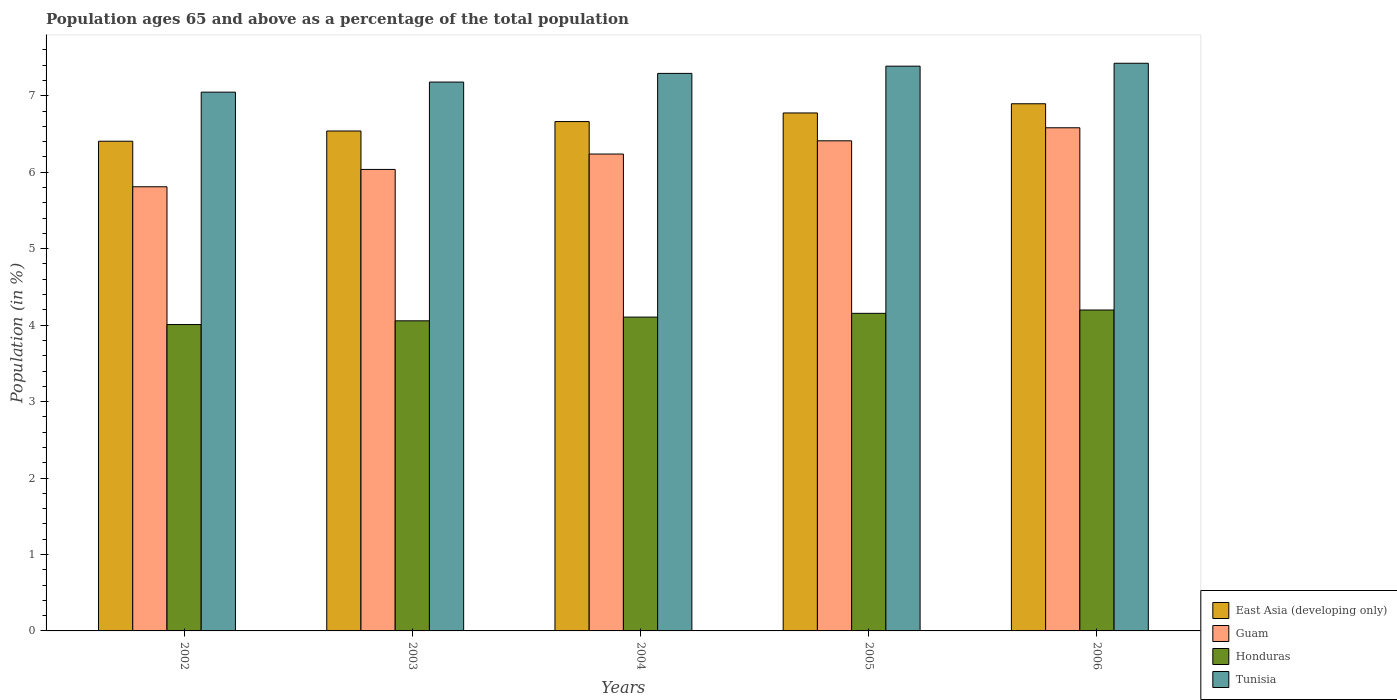How many groups of bars are there?
Provide a succinct answer. 5. How many bars are there on the 4th tick from the right?
Provide a short and direct response. 4. What is the label of the 2nd group of bars from the left?
Provide a succinct answer. 2003. In how many cases, is the number of bars for a given year not equal to the number of legend labels?
Offer a very short reply. 0. What is the percentage of the population ages 65 and above in East Asia (developing only) in 2006?
Your answer should be very brief. 6.9. Across all years, what is the maximum percentage of the population ages 65 and above in East Asia (developing only)?
Give a very brief answer. 6.9. Across all years, what is the minimum percentage of the population ages 65 and above in Guam?
Provide a short and direct response. 5.81. In which year was the percentage of the population ages 65 and above in Guam maximum?
Your answer should be compact. 2006. In which year was the percentage of the population ages 65 and above in Honduras minimum?
Provide a short and direct response. 2002. What is the total percentage of the population ages 65 and above in East Asia (developing only) in the graph?
Provide a short and direct response. 33.28. What is the difference between the percentage of the population ages 65 and above in Honduras in 2005 and that in 2006?
Offer a very short reply. -0.04. What is the difference between the percentage of the population ages 65 and above in Honduras in 2006 and the percentage of the population ages 65 and above in Guam in 2002?
Your answer should be compact. -1.61. What is the average percentage of the population ages 65 and above in Guam per year?
Offer a very short reply. 6.22. In the year 2002, what is the difference between the percentage of the population ages 65 and above in Guam and percentage of the population ages 65 and above in Tunisia?
Provide a succinct answer. -1.24. In how many years, is the percentage of the population ages 65 and above in Guam greater than 6.8?
Offer a very short reply. 0. What is the ratio of the percentage of the population ages 65 and above in Guam in 2003 to that in 2004?
Your response must be concise. 0.97. Is the difference between the percentage of the population ages 65 and above in Guam in 2002 and 2003 greater than the difference between the percentage of the population ages 65 and above in Tunisia in 2002 and 2003?
Offer a very short reply. No. What is the difference between the highest and the second highest percentage of the population ages 65 and above in Honduras?
Your answer should be very brief. 0.04. What is the difference between the highest and the lowest percentage of the population ages 65 and above in Honduras?
Offer a terse response. 0.19. In how many years, is the percentage of the population ages 65 and above in Guam greater than the average percentage of the population ages 65 and above in Guam taken over all years?
Make the answer very short. 3. Is the sum of the percentage of the population ages 65 and above in Guam in 2004 and 2006 greater than the maximum percentage of the population ages 65 and above in Tunisia across all years?
Keep it short and to the point. Yes. Is it the case that in every year, the sum of the percentage of the population ages 65 and above in East Asia (developing only) and percentage of the population ages 65 and above in Guam is greater than the sum of percentage of the population ages 65 and above in Tunisia and percentage of the population ages 65 and above in Honduras?
Keep it short and to the point. No. What does the 2nd bar from the left in 2002 represents?
Give a very brief answer. Guam. What does the 2nd bar from the right in 2002 represents?
Your answer should be very brief. Honduras. Is it the case that in every year, the sum of the percentage of the population ages 65 and above in East Asia (developing only) and percentage of the population ages 65 and above in Guam is greater than the percentage of the population ages 65 and above in Tunisia?
Your answer should be compact. Yes. How many bars are there?
Provide a short and direct response. 20. Are all the bars in the graph horizontal?
Ensure brevity in your answer.  No. What is the difference between two consecutive major ticks on the Y-axis?
Provide a short and direct response. 1. Are the values on the major ticks of Y-axis written in scientific E-notation?
Provide a short and direct response. No. How are the legend labels stacked?
Ensure brevity in your answer.  Vertical. What is the title of the graph?
Offer a very short reply. Population ages 65 and above as a percentage of the total population. Does "Equatorial Guinea" appear as one of the legend labels in the graph?
Provide a short and direct response. No. What is the label or title of the X-axis?
Make the answer very short. Years. What is the label or title of the Y-axis?
Make the answer very short. Population (in %). What is the Population (in %) in East Asia (developing only) in 2002?
Offer a very short reply. 6.41. What is the Population (in %) in Guam in 2002?
Provide a short and direct response. 5.81. What is the Population (in %) in Honduras in 2002?
Offer a very short reply. 4.01. What is the Population (in %) of Tunisia in 2002?
Provide a succinct answer. 7.05. What is the Population (in %) of East Asia (developing only) in 2003?
Offer a very short reply. 6.54. What is the Population (in %) of Guam in 2003?
Give a very brief answer. 6.04. What is the Population (in %) in Honduras in 2003?
Make the answer very short. 4.06. What is the Population (in %) in Tunisia in 2003?
Offer a very short reply. 7.18. What is the Population (in %) of East Asia (developing only) in 2004?
Provide a short and direct response. 6.66. What is the Population (in %) of Guam in 2004?
Your response must be concise. 6.24. What is the Population (in %) of Honduras in 2004?
Give a very brief answer. 4.11. What is the Population (in %) of Tunisia in 2004?
Keep it short and to the point. 7.29. What is the Population (in %) in East Asia (developing only) in 2005?
Keep it short and to the point. 6.78. What is the Population (in %) of Guam in 2005?
Your response must be concise. 6.41. What is the Population (in %) in Honduras in 2005?
Provide a short and direct response. 4.15. What is the Population (in %) in Tunisia in 2005?
Ensure brevity in your answer.  7.39. What is the Population (in %) in East Asia (developing only) in 2006?
Offer a very short reply. 6.9. What is the Population (in %) of Guam in 2006?
Offer a terse response. 6.58. What is the Population (in %) in Honduras in 2006?
Ensure brevity in your answer.  4.2. What is the Population (in %) in Tunisia in 2006?
Provide a short and direct response. 7.43. Across all years, what is the maximum Population (in %) in East Asia (developing only)?
Your answer should be compact. 6.9. Across all years, what is the maximum Population (in %) in Guam?
Your answer should be very brief. 6.58. Across all years, what is the maximum Population (in %) of Honduras?
Offer a very short reply. 4.2. Across all years, what is the maximum Population (in %) of Tunisia?
Ensure brevity in your answer.  7.43. Across all years, what is the minimum Population (in %) of East Asia (developing only)?
Your answer should be very brief. 6.41. Across all years, what is the minimum Population (in %) in Guam?
Offer a very short reply. 5.81. Across all years, what is the minimum Population (in %) in Honduras?
Your answer should be very brief. 4.01. Across all years, what is the minimum Population (in %) in Tunisia?
Provide a succinct answer. 7.05. What is the total Population (in %) in East Asia (developing only) in the graph?
Your answer should be compact. 33.28. What is the total Population (in %) of Guam in the graph?
Offer a very short reply. 31.08. What is the total Population (in %) in Honduras in the graph?
Your answer should be compact. 20.52. What is the total Population (in %) of Tunisia in the graph?
Ensure brevity in your answer.  36.34. What is the difference between the Population (in %) in East Asia (developing only) in 2002 and that in 2003?
Keep it short and to the point. -0.13. What is the difference between the Population (in %) in Guam in 2002 and that in 2003?
Keep it short and to the point. -0.23. What is the difference between the Population (in %) of Honduras in 2002 and that in 2003?
Provide a short and direct response. -0.05. What is the difference between the Population (in %) in Tunisia in 2002 and that in 2003?
Offer a very short reply. -0.13. What is the difference between the Population (in %) of East Asia (developing only) in 2002 and that in 2004?
Provide a succinct answer. -0.26. What is the difference between the Population (in %) in Guam in 2002 and that in 2004?
Provide a succinct answer. -0.43. What is the difference between the Population (in %) in Honduras in 2002 and that in 2004?
Offer a terse response. -0.1. What is the difference between the Population (in %) of Tunisia in 2002 and that in 2004?
Ensure brevity in your answer.  -0.25. What is the difference between the Population (in %) in East Asia (developing only) in 2002 and that in 2005?
Your response must be concise. -0.37. What is the difference between the Population (in %) of Guam in 2002 and that in 2005?
Ensure brevity in your answer.  -0.6. What is the difference between the Population (in %) in Honduras in 2002 and that in 2005?
Offer a terse response. -0.15. What is the difference between the Population (in %) of Tunisia in 2002 and that in 2005?
Make the answer very short. -0.34. What is the difference between the Population (in %) of East Asia (developing only) in 2002 and that in 2006?
Your answer should be very brief. -0.49. What is the difference between the Population (in %) in Guam in 2002 and that in 2006?
Your answer should be compact. -0.77. What is the difference between the Population (in %) of Honduras in 2002 and that in 2006?
Your answer should be very brief. -0.19. What is the difference between the Population (in %) of Tunisia in 2002 and that in 2006?
Offer a very short reply. -0.38. What is the difference between the Population (in %) in East Asia (developing only) in 2003 and that in 2004?
Provide a succinct answer. -0.12. What is the difference between the Population (in %) in Guam in 2003 and that in 2004?
Provide a succinct answer. -0.2. What is the difference between the Population (in %) of Honduras in 2003 and that in 2004?
Your answer should be very brief. -0.05. What is the difference between the Population (in %) of Tunisia in 2003 and that in 2004?
Provide a succinct answer. -0.11. What is the difference between the Population (in %) of East Asia (developing only) in 2003 and that in 2005?
Your response must be concise. -0.24. What is the difference between the Population (in %) of Guam in 2003 and that in 2005?
Ensure brevity in your answer.  -0.37. What is the difference between the Population (in %) in Honduras in 2003 and that in 2005?
Your response must be concise. -0.1. What is the difference between the Population (in %) of Tunisia in 2003 and that in 2005?
Your response must be concise. -0.21. What is the difference between the Population (in %) of East Asia (developing only) in 2003 and that in 2006?
Give a very brief answer. -0.36. What is the difference between the Population (in %) of Guam in 2003 and that in 2006?
Keep it short and to the point. -0.55. What is the difference between the Population (in %) in Honduras in 2003 and that in 2006?
Provide a succinct answer. -0.14. What is the difference between the Population (in %) in Tunisia in 2003 and that in 2006?
Offer a terse response. -0.25. What is the difference between the Population (in %) in East Asia (developing only) in 2004 and that in 2005?
Offer a terse response. -0.11. What is the difference between the Population (in %) in Guam in 2004 and that in 2005?
Your response must be concise. -0.17. What is the difference between the Population (in %) of Honduras in 2004 and that in 2005?
Ensure brevity in your answer.  -0.05. What is the difference between the Population (in %) of Tunisia in 2004 and that in 2005?
Your response must be concise. -0.09. What is the difference between the Population (in %) of East Asia (developing only) in 2004 and that in 2006?
Offer a very short reply. -0.23. What is the difference between the Population (in %) of Guam in 2004 and that in 2006?
Ensure brevity in your answer.  -0.34. What is the difference between the Population (in %) in Honduras in 2004 and that in 2006?
Offer a terse response. -0.09. What is the difference between the Population (in %) in Tunisia in 2004 and that in 2006?
Ensure brevity in your answer.  -0.13. What is the difference between the Population (in %) of East Asia (developing only) in 2005 and that in 2006?
Your response must be concise. -0.12. What is the difference between the Population (in %) in Guam in 2005 and that in 2006?
Give a very brief answer. -0.17. What is the difference between the Population (in %) of Honduras in 2005 and that in 2006?
Your answer should be compact. -0.04. What is the difference between the Population (in %) of Tunisia in 2005 and that in 2006?
Offer a terse response. -0.04. What is the difference between the Population (in %) of East Asia (developing only) in 2002 and the Population (in %) of Guam in 2003?
Your response must be concise. 0.37. What is the difference between the Population (in %) of East Asia (developing only) in 2002 and the Population (in %) of Honduras in 2003?
Keep it short and to the point. 2.35. What is the difference between the Population (in %) in East Asia (developing only) in 2002 and the Population (in %) in Tunisia in 2003?
Give a very brief answer. -0.77. What is the difference between the Population (in %) of Guam in 2002 and the Population (in %) of Honduras in 2003?
Your response must be concise. 1.75. What is the difference between the Population (in %) in Guam in 2002 and the Population (in %) in Tunisia in 2003?
Keep it short and to the point. -1.37. What is the difference between the Population (in %) of Honduras in 2002 and the Population (in %) of Tunisia in 2003?
Keep it short and to the point. -3.17. What is the difference between the Population (in %) of East Asia (developing only) in 2002 and the Population (in %) of Guam in 2004?
Keep it short and to the point. 0.17. What is the difference between the Population (in %) of East Asia (developing only) in 2002 and the Population (in %) of Honduras in 2004?
Provide a short and direct response. 2.3. What is the difference between the Population (in %) in East Asia (developing only) in 2002 and the Population (in %) in Tunisia in 2004?
Your answer should be compact. -0.89. What is the difference between the Population (in %) in Guam in 2002 and the Population (in %) in Honduras in 2004?
Your response must be concise. 1.7. What is the difference between the Population (in %) of Guam in 2002 and the Population (in %) of Tunisia in 2004?
Your answer should be very brief. -1.48. What is the difference between the Population (in %) in Honduras in 2002 and the Population (in %) in Tunisia in 2004?
Your answer should be compact. -3.29. What is the difference between the Population (in %) of East Asia (developing only) in 2002 and the Population (in %) of Guam in 2005?
Make the answer very short. -0.01. What is the difference between the Population (in %) of East Asia (developing only) in 2002 and the Population (in %) of Honduras in 2005?
Offer a very short reply. 2.25. What is the difference between the Population (in %) of East Asia (developing only) in 2002 and the Population (in %) of Tunisia in 2005?
Your answer should be very brief. -0.98. What is the difference between the Population (in %) in Guam in 2002 and the Population (in %) in Honduras in 2005?
Offer a terse response. 1.66. What is the difference between the Population (in %) of Guam in 2002 and the Population (in %) of Tunisia in 2005?
Your response must be concise. -1.58. What is the difference between the Population (in %) in Honduras in 2002 and the Population (in %) in Tunisia in 2005?
Provide a succinct answer. -3.38. What is the difference between the Population (in %) in East Asia (developing only) in 2002 and the Population (in %) in Guam in 2006?
Provide a short and direct response. -0.18. What is the difference between the Population (in %) of East Asia (developing only) in 2002 and the Population (in %) of Honduras in 2006?
Make the answer very short. 2.21. What is the difference between the Population (in %) of East Asia (developing only) in 2002 and the Population (in %) of Tunisia in 2006?
Offer a terse response. -1.02. What is the difference between the Population (in %) in Guam in 2002 and the Population (in %) in Honduras in 2006?
Provide a short and direct response. 1.61. What is the difference between the Population (in %) in Guam in 2002 and the Population (in %) in Tunisia in 2006?
Keep it short and to the point. -1.62. What is the difference between the Population (in %) of Honduras in 2002 and the Population (in %) of Tunisia in 2006?
Give a very brief answer. -3.42. What is the difference between the Population (in %) of East Asia (developing only) in 2003 and the Population (in %) of Guam in 2004?
Ensure brevity in your answer.  0.3. What is the difference between the Population (in %) of East Asia (developing only) in 2003 and the Population (in %) of Honduras in 2004?
Your answer should be compact. 2.43. What is the difference between the Population (in %) in East Asia (developing only) in 2003 and the Population (in %) in Tunisia in 2004?
Offer a terse response. -0.75. What is the difference between the Population (in %) of Guam in 2003 and the Population (in %) of Honduras in 2004?
Provide a short and direct response. 1.93. What is the difference between the Population (in %) of Guam in 2003 and the Population (in %) of Tunisia in 2004?
Provide a short and direct response. -1.26. What is the difference between the Population (in %) in Honduras in 2003 and the Population (in %) in Tunisia in 2004?
Ensure brevity in your answer.  -3.24. What is the difference between the Population (in %) in East Asia (developing only) in 2003 and the Population (in %) in Guam in 2005?
Offer a terse response. 0.13. What is the difference between the Population (in %) of East Asia (developing only) in 2003 and the Population (in %) of Honduras in 2005?
Keep it short and to the point. 2.39. What is the difference between the Population (in %) in East Asia (developing only) in 2003 and the Population (in %) in Tunisia in 2005?
Your answer should be very brief. -0.85. What is the difference between the Population (in %) in Guam in 2003 and the Population (in %) in Honduras in 2005?
Offer a terse response. 1.88. What is the difference between the Population (in %) of Guam in 2003 and the Population (in %) of Tunisia in 2005?
Provide a succinct answer. -1.35. What is the difference between the Population (in %) in Honduras in 2003 and the Population (in %) in Tunisia in 2005?
Your answer should be compact. -3.33. What is the difference between the Population (in %) of East Asia (developing only) in 2003 and the Population (in %) of Guam in 2006?
Your answer should be very brief. -0.04. What is the difference between the Population (in %) of East Asia (developing only) in 2003 and the Population (in %) of Honduras in 2006?
Provide a short and direct response. 2.34. What is the difference between the Population (in %) of East Asia (developing only) in 2003 and the Population (in %) of Tunisia in 2006?
Offer a terse response. -0.89. What is the difference between the Population (in %) of Guam in 2003 and the Population (in %) of Honduras in 2006?
Ensure brevity in your answer.  1.84. What is the difference between the Population (in %) in Guam in 2003 and the Population (in %) in Tunisia in 2006?
Provide a short and direct response. -1.39. What is the difference between the Population (in %) of Honduras in 2003 and the Population (in %) of Tunisia in 2006?
Give a very brief answer. -3.37. What is the difference between the Population (in %) of East Asia (developing only) in 2004 and the Population (in %) of Guam in 2005?
Provide a succinct answer. 0.25. What is the difference between the Population (in %) in East Asia (developing only) in 2004 and the Population (in %) in Honduras in 2005?
Your response must be concise. 2.51. What is the difference between the Population (in %) in East Asia (developing only) in 2004 and the Population (in %) in Tunisia in 2005?
Your answer should be very brief. -0.72. What is the difference between the Population (in %) of Guam in 2004 and the Population (in %) of Honduras in 2005?
Offer a terse response. 2.08. What is the difference between the Population (in %) in Guam in 2004 and the Population (in %) in Tunisia in 2005?
Keep it short and to the point. -1.15. What is the difference between the Population (in %) of Honduras in 2004 and the Population (in %) of Tunisia in 2005?
Your answer should be very brief. -3.28. What is the difference between the Population (in %) of East Asia (developing only) in 2004 and the Population (in %) of Guam in 2006?
Keep it short and to the point. 0.08. What is the difference between the Population (in %) in East Asia (developing only) in 2004 and the Population (in %) in Honduras in 2006?
Your answer should be compact. 2.46. What is the difference between the Population (in %) of East Asia (developing only) in 2004 and the Population (in %) of Tunisia in 2006?
Give a very brief answer. -0.76. What is the difference between the Population (in %) of Guam in 2004 and the Population (in %) of Honduras in 2006?
Keep it short and to the point. 2.04. What is the difference between the Population (in %) in Guam in 2004 and the Population (in %) in Tunisia in 2006?
Your answer should be very brief. -1.19. What is the difference between the Population (in %) of Honduras in 2004 and the Population (in %) of Tunisia in 2006?
Ensure brevity in your answer.  -3.32. What is the difference between the Population (in %) of East Asia (developing only) in 2005 and the Population (in %) of Guam in 2006?
Offer a terse response. 0.19. What is the difference between the Population (in %) of East Asia (developing only) in 2005 and the Population (in %) of Honduras in 2006?
Keep it short and to the point. 2.58. What is the difference between the Population (in %) of East Asia (developing only) in 2005 and the Population (in %) of Tunisia in 2006?
Provide a succinct answer. -0.65. What is the difference between the Population (in %) of Guam in 2005 and the Population (in %) of Honduras in 2006?
Ensure brevity in your answer.  2.21. What is the difference between the Population (in %) of Guam in 2005 and the Population (in %) of Tunisia in 2006?
Provide a short and direct response. -1.01. What is the difference between the Population (in %) in Honduras in 2005 and the Population (in %) in Tunisia in 2006?
Your response must be concise. -3.27. What is the average Population (in %) in East Asia (developing only) per year?
Ensure brevity in your answer.  6.66. What is the average Population (in %) in Guam per year?
Keep it short and to the point. 6.22. What is the average Population (in %) of Honduras per year?
Make the answer very short. 4.1. What is the average Population (in %) of Tunisia per year?
Ensure brevity in your answer.  7.27. In the year 2002, what is the difference between the Population (in %) in East Asia (developing only) and Population (in %) in Guam?
Offer a very short reply. 0.6. In the year 2002, what is the difference between the Population (in %) of East Asia (developing only) and Population (in %) of Honduras?
Give a very brief answer. 2.4. In the year 2002, what is the difference between the Population (in %) in East Asia (developing only) and Population (in %) in Tunisia?
Offer a terse response. -0.64. In the year 2002, what is the difference between the Population (in %) in Guam and Population (in %) in Honduras?
Make the answer very short. 1.8. In the year 2002, what is the difference between the Population (in %) of Guam and Population (in %) of Tunisia?
Provide a succinct answer. -1.24. In the year 2002, what is the difference between the Population (in %) of Honduras and Population (in %) of Tunisia?
Your answer should be very brief. -3.04. In the year 2003, what is the difference between the Population (in %) of East Asia (developing only) and Population (in %) of Guam?
Provide a succinct answer. 0.5. In the year 2003, what is the difference between the Population (in %) of East Asia (developing only) and Population (in %) of Honduras?
Your answer should be very brief. 2.48. In the year 2003, what is the difference between the Population (in %) of East Asia (developing only) and Population (in %) of Tunisia?
Provide a succinct answer. -0.64. In the year 2003, what is the difference between the Population (in %) of Guam and Population (in %) of Honduras?
Provide a succinct answer. 1.98. In the year 2003, what is the difference between the Population (in %) in Guam and Population (in %) in Tunisia?
Your answer should be compact. -1.14. In the year 2003, what is the difference between the Population (in %) of Honduras and Population (in %) of Tunisia?
Provide a succinct answer. -3.12. In the year 2004, what is the difference between the Population (in %) in East Asia (developing only) and Population (in %) in Guam?
Your response must be concise. 0.42. In the year 2004, what is the difference between the Population (in %) of East Asia (developing only) and Population (in %) of Honduras?
Your answer should be very brief. 2.56. In the year 2004, what is the difference between the Population (in %) of East Asia (developing only) and Population (in %) of Tunisia?
Offer a very short reply. -0.63. In the year 2004, what is the difference between the Population (in %) in Guam and Population (in %) in Honduras?
Make the answer very short. 2.13. In the year 2004, what is the difference between the Population (in %) of Guam and Population (in %) of Tunisia?
Provide a succinct answer. -1.05. In the year 2004, what is the difference between the Population (in %) of Honduras and Population (in %) of Tunisia?
Offer a terse response. -3.19. In the year 2005, what is the difference between the Population (in %) in East Asia (developing only) and Population (in %) in Guam?
Provide a short and direct response. 0.36. In the year 2005, what is the difference between the Population (in %) in East Asia (developing only) and Population (in %) in Honduras?
Provide a short and direct response. 2.62. In the year 2005, what is the difference between the Population (in %) in East Asia (developing only) and Population (in %) in Tunisia?
Provide a short and direct response. -0.61. In the year 2005, what is the difference between the Population (in %) of Guam and Population (in %) of Honduras?
Your answer should be compact. 2.26. In the year 2005, what is the difference between the Population (in %) of Guam and Population (in %) of Tunisia?
Offer a very short reply. -0.98. In the year 2005, what is the difference between the Population (in %) of Honduras and Population (in %) of Tunisia?
Make the answer very short. -3.23. In the year 2006, what is the difference between the Population (in %) of East Asia (developing only) and Population (in %) of Guam?
Provide a succinct answer. 0.31. In the year 2006, what is the difference between the Population (in %) in East Asia (developing only) and Population (in %) in Honduras?
Your answer should be compact. 2.7. In the year 2006, what is the difference between the Population (in %) in East Asia (developing only) and Population (in %) in Tunisia?
Your answer should be compact. -0.53. In the year 2006, what is the difference between the Population (in %) in Guam and Population (in %) in Honduras?
Give a very brief answer. 2.38. In the year 2006, what is the difference between the Population (in %) of Guam and Population (in %) of Tunisia?
Ensure brevity in your answer.  -0.84. In the year 2006, what is the difference between the Population (in %) in Honduras and Population (in %) in Tunisia?
Keep it short and to the point. -3.23. What is the ratio of the Population (in %) in East Asia (developing only) in 2002 to that in 2003?
Ensure brevity in your answer.  0.98. What is the ratio of the Population (in %) of Guam in 2002 to that in 2003?
Provide a short and direct response. 0.96. What is the ratio of the Population (in %) of Honduras in 2002 to that in 2003?
Make the answer very short. 0.99. What is the ratio of the Population (in %) of Tunisia in 2002 to that in 2003?
Offer a very short reply. 0.98. What is the ratio of the Population (in %) of East Asia (developing only) in 2002 to that in 2004?
Your answer should be compact. 0.96. What is the ratio of the Population (in %) of Guam in 2002 to that in 2004?
Your answer should be compact. 0.93. What is the ratio of the Population (in %) of Honduras in 2002 to that in 2004?
Make the answer very short. 0.98. What is the ratio of the Population (in %) of Tunisia in 2002 to that in 2004?
Offer a very short reply. 0.97. What is the ratio of the Population (in %) in East Asia (developing only) in 2002 to that in 2005?
Make the answer very short. 0.95. What is the ratio of the Population (in %) in Guam in 2002 to that in 2005?
Offer a terse response. 0.91. What is the ratio of the Population (in %) of Honduras in 2002 to that in 2005?
Offer a terse response. 0.96. What is the ratio of the Population (in %) in Tunisia in 2002 to that in 2005?
Your answer should be very brief. 0.95. What is the ratio of the Population (in %) in East Asia (developing only) in 2002 to that in 2006?
Your response must be concise. 0.93. What is the ratio of the Population (in %) of Guam in 2002 to that in 2006?
Your answer should be compact. 0.88. What is the ratio of the Population (in %) in Honduras in 2002 to that in 2006?
Ensure brevity in your answer.  0.95. What is the ratio of the Population (in %) of Tunisia in 2002 to that in 2006?
Your answer should be compact. 0.95. What is the ratio of the Population (in %) of East Asia (developing only) in 2003 to that in 2004?
Keep it short and to the point. 0.98. What is the ratio of the Population (in %) of Tunisia in 2003 to that in 2004?
Your response must be concise. 0.98. What is the ratio of the Population (in %) of East Asia (developing only) in 2003 to that in 2005?
Offer a very short reply. 0.97. What is the ratio of the Population (in %) in Guam in 2003 to that in 2005?
Your answer should be very brief. 0.94. What is the ratio of the Population (in %) of Honduras in 2003 to that in 2005?
Offer a terse response. 0.98. What is the ratio of the Population (in %) in Tunisia in 2003 to that in 2005?
Offer a terse response. 0.97. What is the ratio of the Population (in %) in East Asia (developing only) in 2003 to that in 2006?
Provide a short and direct response. 0.95. What is the ratio of the Population (in %) of Guam in 2003 to that in 2006?
Your answer should be compact. 0.92. What is the ratio of the Population (in %) of Honduras in 2003 to that in 2006?
Keep it short and to the point. 0.97. What is the ratio of the Population (in %) of Tunisia in 2003 to that in 2006?
Your answer should be very brief. 0.97. What is the ratio of the Population (in %) in East Asia (developing only) in 2004 to that in 2005?
Ensure brevity in your answer.  0.98. What is the ratio of the Population (in %) in Guam in 2004 to that in 2005?
Ensure brevity in your answer.  0.97. What is the ratio of the Population (in %) of Honduras in 2004 to that in 2005?
Keep it short and to the point. 0.99. What is the ratio of the Population (in %) in Tunisia in 2004 to that in 2005?
Your answer should be compact. 0.99. What is the ratio of the Population (in %) in East Asia (developing only) in 2004 to that in 2006?
Your answer should be compact. 0.97. What is the ratio of the Population (in %) of Guam in 2004 to that in 2006?
Keep it short and to the point. 0.95. What is the ratio of the Population (in %) in Honduras in 2004 to that in 2006?
Your response must be concise. 0.98. What is the ratio of the Population (in %) in Tunisia in 2004 to that in 2006?
Your response must be concise. 0.98. What is the ratio of the Population (in %) in East Asia (developing only) in 2005 to that in 2006?
Your response must be concise. 0.98. What is the ratio of the Population (in %) in Guam in 2005 to that in 2006?
Your answer should be very brief. 0.97. What is the ratio of the Population (in %) in Tunisia in 2005 to that in 2006?
Offer a very short reply. 0.99. What is the difference between the highest and the second highest Population (in %) of East Asia (developing only)?
Provide a succinct answer. 0.12. What is the difference between the highest and the second highest Population (in %) in Guam?
Ensure brevity in your answer.  0.17. What is the difference between the highest and the second highest Population (in %) of Honduras?
Give a very brief answer. 0.04. What is the difference between the highest and the second highest Population (in %) in Tunisia?
Give a very brief answer. 0.04. What is the difference between the highest and the lowest Population (in %) in East Asia (developing only)?
Your response must be concise. 0.49. What is the difference between the highest and the lowest Population (in %) of Guam?
Provide a succinct answer. 0.77. What is the difference between the highest and the lowest Population (in %) in Honduras?
Ensure brevity in your answer.  0.19. What is the difference between the highest and the lowest Population (in %) in Tunisia?
Provide a succinct answer. 0.38. 